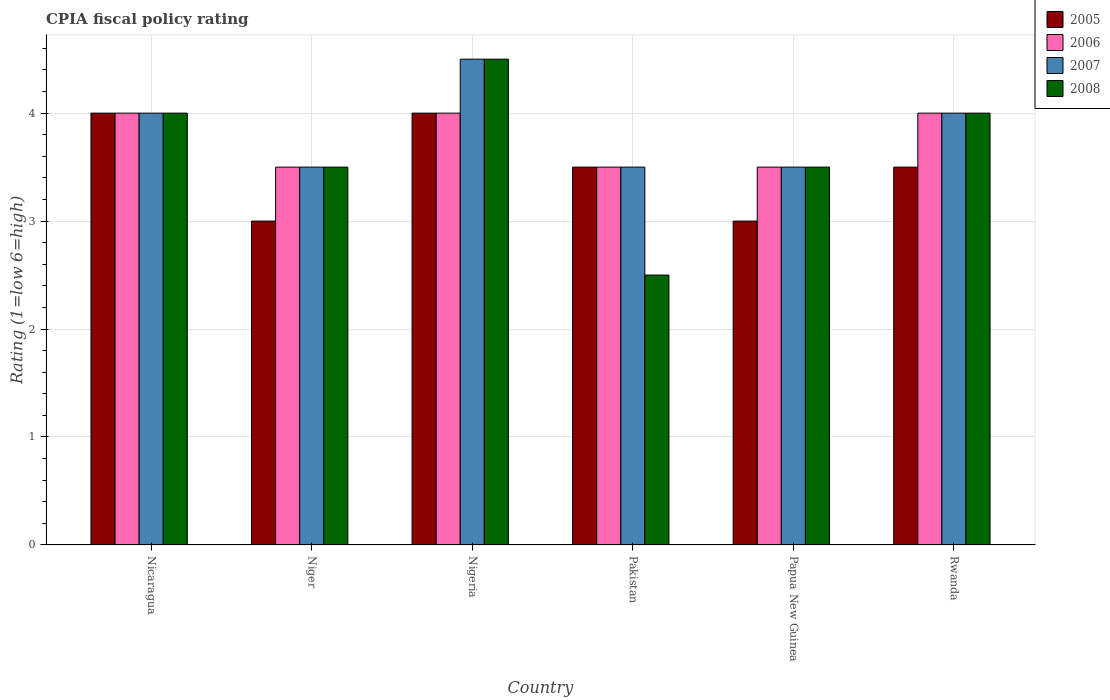How many different coloured bars are there?
Keep it short and to the point. 4. Are the number of bars on each tick of the X-axis equal?
Offer a terse response. Yes. How many bars are there on the 2nd tick from the left?
Provide a short and direct response. 4. What is the label of the 1st group of bars from the left?
Ensure brevity in your answer.  Nicaragua. In how many cases, is the number of bars for a given country not equal to the number of legend labels?
Provide a succinct answer. 0. What is the CPIA rating in 2008 in Rwanda?
Give a very brief answer. 4. Across all countries, what is the minimum CPIA rating in 2006?
Offer a very short reply. 3.5. In which country was the CPIA rating in 2008 maximum?
Give a very brief answer. Nigeria. In which country was the CPIA rating in 2006 minimum?
Offer a terse response. Niger. What is the difference between the CPIA rating in 2007 in Nigeria and the CPIA rating in 2006 in Rwanda?
Provide a short and direct response. 0.5. What is the average CPIA rating in 2008 per country?
Your response must be concise. 3.67. What is the difference between the CPIA rating of/in 2005 and CPIA rating of/in 2006 in Nicaragua?
Your answer should be compact. 0. What is the ratio of the CPIA rating in 2006 in Nicaragua to that in Rwanda?
Your response must be concise. 1. Is it the case that in every country, the sum of the CPIA rating in 2005 and CPIA rating in 2006 is greater than the sum of CPIA rating in 2008 and CPIA rating in 2007?
Offer a terse response. No. What does the 1st bar from the left in Rwanda represents?
Keep it short and to the point. 2005. What does the 3rd bar from the right in Rwanda represents?
Your response must be concise. 2006. Are all the bars in the graph horizontal?
Offer a very short reply. No. Are the values on the major ticks of Y-axis written in scientific E-notation?
Keep it short and to the point. No. Does the graph contain any zero values?
Provide a succinct answer. No. Where does the legend appear in the graph?
Provide a short and direct response. Top right. How are the legend labels stacked?
Offer a terse response. Vertical. What is the title of the graph?
Provide a succinct answer. CPIA fiscal policy rating. What is the label or title of the X-axis?
Keep it short and to the point. Country. What is the Rating (1=low 6=high) of 2005 in Nicaragua?
Your answer should be compact. 4. What is the Rating (1=low 6=high) of 2007 in Nicaragua?
Provide a succinct answer. 4. What is the Rating (1=low 6=high) of 2006 in Niger?
Offer a very short reply. 3.5. What is the Rating (1=low 6=high) in 2007 in Niger?
Ensure brevity in your answer.  3.5. What is the Rating (1=low 6=high) of 2006 in Nigeria?
Your response must be concise. 4. What is the Rating (1=low 6=high) of 2008 in Nigeria?
Your answer should be compact. 4.5. What is the Rating (1=low 6=high) in 2005 in Papua New Guinea?
Make the answer very short. 3. What is the Rating (1=low 6=high) in 2006 in Papua New Guinea?
Ensure brevity in your answer.  3.5. What is the Rating (1=low 6=high) in 2005 in Rwanda?
Your answer should be compact. 3.5. Across all countries, what is the maximum Rating (1=low 6=high) of 2006?
Ensure brevity in your answer.  4. Across all countries, what is the minimum Rating (1=low 6=high) of 2008?
Your response must be concise. 2.5. What is the total Rating (1=low 6=high) in 2005 in the graph?
Provide a succinct answer. 21. What is the total Rating (1=low 6=high) of 2007 in the graph?
Give a very brief answer. 23. What is the difference between the Rating (1=low 6=high) in 2005 in Nicaragua and that in Niger?
Your answer should be compact. 1. What is the difference between the Rating (1=low 6=high) of 2007 in Nicaragua and that in Niger?
Your response must be concise. 0.5. What is the difference between the Rating (1=low 6=high) of 2008 in Nicaragua and that in Niger?
Your response must be concise. 0.5. What is the difference between the Rating (1=low 6=high) of 2005 in Nicaragua and that in Nigeria?
Ensure brevity in your answer.  0. What is the difference between the Rating (1=low 6=high) in 2006 in Nicaragua and that in Nigeria?
Make the answer very short. 0. What is the difference between the Rating (1=low 6=high) of 2008 in Nicaragua and that in Nigeria?
Provide a succinct answer. -0.5. What is the difference between the Rating (1=low 6=high) in 2005 in Nicaragua and that in Pakistan?
Provide a succinct answer. 0.5. What is the difference between the Rating (1=low 6=high) of 2008 in Nicaragua and that in Pakistan?
Provide a short and direct response. 1.5. What is the difference between the Rating (1=low 6=high) in 2006 in Nicaragua and that in Rwanda?
Make the answer very short. 0. What is the difference between the Rating (1=low 6=high) in 2008 in Nicaragua and that in Rwanda?
Provide a short and direct response. 0. What is the difference between the Rating (1=low 6=high) of 2005 in Niger and that in Nigeria?
Offer a terse response. -1. What is the difference between the Rating (1=low 6=high) in 2006 in Niger and that in Nigeria?
Your answer should be very brief. -0.5. What is the difference between the Rating (1=low 6=high) of 2007 in Niger and that in Nigeria?
Provide a succinct answer. -1. What is the difference between the Rating (1=low 6=high) of 2008 in Niger and that in Nigeria?
Make the answer very short. -1. What is the difference between the Rating (1=low 6=high) of 2006 in Niger and that in Pakistan?
Make the answer very short. 0. What is the difference between the Rating (1=low 6=high) in 2007 in Niger and that in Pakistan?
Give a very brief answer. 0. What is the difference between the Rating (1=low 6=high) of 2005 in Niger and that in Papua New Guinea?
Give a very brief answer. 0. What is the difference between the Rating (1=low 6=high) of 2006 in Niger and that in Papua New Guinea?
Offer a very short reply. 0. What is the difference between the Rating (1=low 6=high) in 2007 in Niger and that in Papua New Guinea?
Offer a terse response. 0. What is the difference between the Rating (1=low 6=high) of 2008 in Niger and that in Rwanda?
Your answer should be very brief. -0.5. What is the difference between the Rating (1=low 6=high) of 2006 in Nigeria and that in Pakistan?
Provide a short and direct response. 0.5. What is the difference between the Rating (1=low 6=high) of 2007 in Nigeria and that in Pakistan?
Offer a very short reply. 1. What is the difference between the Rating (1=low 6=high) of 2006 in Nigeria and that in Rwanda?
Keep it short and to the point. 0. What is the difference between the Rating (1=low 6=high) of 2007 in Nigeria and that in Rwanda?
Make the answer very short. 0.5. What is the difference between the Rating (1=low 6=high) of 2008 in Nigeria and that in Rwanda?
Offer a terse response. 0.5. What is the difference between the Rating (1=low 6=high) of 2007 in Pakistan and that in Papua New Guinea?
Make the answer very short. 0. What is the difference between the Rating (1=low 6=high) of 2008 in Pakistan and that in Papua New Guinea?
Offer a very short reply. -1. What is the difference between the Rating (1=low 6=high) of 2005 in Pakistan and that in Rwanda?
Keep it short and to the point. 0. What is the difference between the Rating (1=low 6=high) in 2007 in Pakistan and that in Rwanda?
Keep it short and to the point. -0.5. What is the difference between the Rating (1=low 6=high) in 2005 in Papua New Guinea and that in Rwanda?
Your response must be concise. -0.5. What is the difference between the Rating (1=low 6=high) of 2006 in Papua New Guinea and that in Rwanda?
Offer a very short reply. -0.5. What is the difference between the Rating (1=low 6=high) of 2007 in Papua New Guinea and that in Rwanda?
Ensure brevity in your answer.  -0.5. What is the difference between the Rating (1=low 6=high) of 2008 in Papua New Guinea and that in Rwanda?
Keep it short and to the point. -0.5. What is the difference between the Rating (1=low 6=high) of 2005 in Nicaragua and the Rating (1=low 6=high) of 2006 in Niger?
Provide a succinct answer. 0.5. What is the difference between the Rating (1=low 6=high) of 2005 in Nicaragua and the Rating (1=low 6=high) of 2007 in Niger?
Give a very brief answer. 0.5. What is the difference between the Rating (1=low 6=high) of 2005 in Nicaragua and the Rating (1=low 6=high) of 2008 in Niger?
Offer a terse response. 0.5. What is the difference between the Rating (1=low 6=high) of 2006 in Nicaragua and the Rating (1=low 6=high) of 2007 in Niger?
Your response must be concise. 0.5. What is the difference between the Rating (1=low 6=high) in 2006 in Nicaragua and the Rating (1=low 6=high) in 2008 in Nigeria?
Your answer should be very brief. -0.5. What is the difference between the Rating (1=low 6=high) in 2007 in Nicaragua and the Rating (1=low 6=high) in 2008 in Nigeria?
Ensure brevity in your answer.  -0.5. What is the difference between the Rating (1=low 6=high) of 2005 in Nicaragua and the Rating (1=low 6=high) of 2007 in Pakistan?
Your answer should be very brief. 0.5. What is the difference between the Rating (1=low 6=high) in 2005 in Nicaragua and the Rating (1=low 6=high) in 2008 in Pakistan?
Make the answer very short. 1.5. What is the difference between the Rating (1=low 6=high) in 2006 in Nicaragua and the Rating (1=low 6=high) in 2007 in Pakistan?
Offer a terse response. 0.5. What is the difference between the Rating (1=low 6=high) of 2006 in Nicaragua and the Rating (1=low 6=high) of 2008 in Pakistan?
Give a very brief answer. 1.5. What is the difference between the Rating (1=low 6=high) in 2005 in Nicaragua and the Rating (1=low 6=high) in 2007 in Papua New Guinea?
Your answer should be compact. 0.5. What is the difference between the Rating (1=low 6=high) of 2005 in Nicaragua and the Rating (1=low 6=high) of 2008 in Papua New Guinea?
Give a very brief answer. 0.5. What is the difference between the Rating (1=low 6=high) in 2006 in Nicaragua and the Rating (1=low 6=high) in 2008 in Papua New Guinea?
Offer a terse response. 0.5. What is the difference between the Rating (1=low 6=high) in 2007 in Nicaragua and the Rating (1=low 6=high) in 2008 in Papua New Guinea?
Offer a terse response. 0.5. What is the difference between the Rating (1=low 6=high) of 2005 in Nicaragua and the Rating (1=low 6=high) of 2006 in Rwanda?
Your answer should be very brief. 0. What is the difference between the Rating (1=low 6=high) in 2005 in Nicaragua and the Rating (1=low 6=high) in 2007 in Rwanda?
Ensure brevity in your answer.  0. What is the difference between the Rating (1=low 6=high) in 2005 in Nicaragua and the Rating (1=low 6=high) in 2008 in Rwanda?
Give a very brief answer. 0. What is the difference between the Rating (1=low 6=high) in 2006 in Nicaragua and the Rating (1=low 6=high) in 2007 in Rwanda?
Give a very brief answer. 0. What is the difference between the Rating (1=low 6=high) of 2006 in Nicaragua and the Rating (1=low 6=high) of 2008 in Rwanda?
Your response must be concise. 0. What is the difference between the Rating (1=low 6=high) in 2007 in Nicaragua and the Rating (1=low 6=high) in 2008 in Rwanda?
Your response must be concise. 0. What is the difference between the Rating (1=low 6=high) of 2005 in Niger and the Rating (1=low 6=high) of 2007 in Nigeria?
Your response must be concise. -1.5. What is the difference between the Rating (1=low 6=high) of 2006 in Niger and the Rating (1=low 6=high) of 2007 in Nigeria?
Ensure brevity in your answer.  -1. What is the difference between the Rating (1=low 6=high) of 2005 in Niger and the Rating (1=low 6=high) of 2007 in Pakistan?
Your answer should be compact. -0.5. What is the difference between the Rating (1=low 6=high) of 2006 in Niger and the Rating (1=low 6=high) of 2008 in Pakistan?
Ensure brevity in your answer.  1. What is the difference between the Rating (1=low 6=high) of 2007 in Niger and the Rating (1=low 6=high) of 2008 in Pakistan?
Ensure brevity in your answer.  1. What is the difference between the Rating (1=low 6=high) in 2005 in Niger and the Rating (1=low 6=high) in 2007 in Papua New Guinea?
Keep it short and to the point. -0.5. What is the difference between the Rating (1=low 6=high) in 2005 in Niger and the Rating (1=low 6=high) in 2008 in Papua New Guinea?
Offer a very short reply. -0.5. What is the difference between the Rating (1=low 6=high) in 2007 in Niger and the Rating (1=low 6=high) in 2008 in Papua New Guinea?
Make the answer very short. 0. What is the difference between the Rating (1=low 6=high) in 2005 in Niger and the Rating (1=low 6=high) in 2006 in Rwanda?
Provide a succinct answer. -1. What is the difference between the Rating (1=low 6=high) in 2005 in Niger and the Rating (1=low 6=high) in 2007 in Rwanda?
Keep it short and to the point. -1. What is the difference between the Rating (1=low 6=high) of 2005 in Niger and the Rating (1=low 6=high) of 2008 in Rwanda?
Your answer should be compact. -1. What is the difference between the Rating (1=low 6=high) of 2005 in Nigeria and the Rating (1=low 6=high) of 2007 in Pakistan?
Make the answer very short. 0.5. What is the difference between the Rating (1=low 6=high) of 2005 in Nigeria and the Rating (1=low 6=high) of 2008 in Pakistan?
Keep it short and to the point. 1.5. What is the difference between the Rating (1=low 6=high) of 2006 in Nigeria and the Rating (1=low 6=high) of 2008 in Pakistan?
Ensure brevity in your answer.  1.5. What is the difference between the Rating (1=low 6=high) of 2005 in Nigeria and the Rating (1=low 6=high) of 2008 in Papua New Guinea?
Ensure brevity in your answer.  0.5. What is the difference between the Rating (1=low 6=high) of 2006 in Nigeria and the Rating (1=low 6=high) of 2008 in Papua New Guinea?
Your response must be concise. 0.5. What is the difference between the Rating (1=low 6=high) in 2005 in Nigeria and the Rating (1=low 6=high) in 2006 in Rwanda?
Keep it short and to the point. 0. What is the difference between the Rating (1=low 6=high) of 2005 in Nigeria and the Rating (1=low 6=high) of 2008 in Rwanda?
Provide a succinct answer. 0. What is the difference between the Rating (1=low 6=high) of 2006 in Pakistan and the Rating (1=low 6=high) of 2007 in Papua New Guinea?
Your answer should be compact. 0. What is the difference between the Rating (1=low 6=high) of 2006 in Pakistan and the Rating (1=low 6=high) of 2008 in Papua New Guinea?
Offer a very short reply. 0. What is the difference between the Rating (1=low 6=high) in 2007 in Pakistan and the Rating (1=low 6=high) in 2008 in Papua New Guinea?
Your answer should be very brief. 0. What is the difference between the Rating (1=low 6=high) in 2005 in Pakistan and the Rating (1=low 6=high) in 2008 in Rwanda?
Your answer should be compact. -0.5. What is the difference between the Rating (1=low 6=high) in 2006 in Pakistan and the Rating (1=low 6=high) in 2007 in Rwanda?
Make the answer very short. -0.5. What is the difference between the Rating (1=low 6=high) of 2006 in Pakistan and the Rating (1=low 6=high) of 2008 in Rwanda?
Offer a very short reply. -0.5. What is the difference between the Rating (1=low 6=high) of 2007 in Pakistan and the Rating (1=low 6=high) of 2008 in Rwanda?
Provide a short and direct response. -0.5. What is the difference between the Rating (1=low 6=high) of 2005 in Papua New Guinea and the Rating (1=low 6=high) of 2006 in Rwanda?
Offer a very short reply. -1. What is the difference between the Rating (1=low 6=high) in 2005 in Papua New Guinea and the Rating (1=low 6=high) in 2007 in Rwanda?
Ensure brevity in your answer.  -1. What is the difference between the Rating (1=low 6=high) in 2006 in Papua New Guinea and the Rating (1=low 6=high) in 2007 in Rwanda?
Your answer should be compact. -0.5. What is the difference between the Rating (1=low 6=high) of 2006 in Papua New Guinea and the Rating (1=low 6=high) of 2008 in Rwanda?
Keep it short and to the point. -0.5. What is the difference between the Rating (1=low 6=high) of 2007 in Papua New Guinea and the Rating (1=low 6=high) of 2008 in Rwanda?
Your answer should be very brief. -0.5. What is the average Rating (1=low 6=high) of 2006 per country?
Provide a short and direct response. 3.75. What is the average Rating (1=low 6=high) of 2007 per country?
Provide a short and direct response. 3.83. What is the average Rating (1=low 6=high) of 2008 per country?
Make the answer very short. 3.67. What is the difference between the Rating (1=low 6=high) in 2005 and Rating (1=low 6=high) in 2007 in Nicaragua?
Offer a terse response. 0. What is the difference between the Rating (1=low 6=high) in 2006 and Rating (1=low 6=high) in 2007 in Nicaragua?
Give a very brief answer. 0. What is the difference between the Rating (1=low 6=high) of 2006 and Rating (1=low 6=high) of 2008 in Nicaragua?
Your answer should be compact. 0. What is the difference between the Rating (1=low 6=high) in 2007 and Rating (1=low 6=high) in 2008 in Nicaragua?
Provide a succinct answer. 0. What is the difference between the Rating (1=low 6=high) in 2005 and Rating (1=low 6=high) in 2006 in Nigeria?
Your answer should be very brief. 0. What is the difference between the Rating (1=low 6=high) of 2005 and Rating (1=low 6=high) of 2007 in Nigeria?
Your response must be concise. -0.5. What is the difference between the Rating (1=low 6=high) in 2005 and Rating (1=low 6=high) in 2008 in Nigeria?
Your answer should be compact. -0.5. What is the difference between the Rating (1=low 6=high) in 2006 and Rating (1=low 6=high) in 2007 in Nigeria?
Provide a succinct answer. -0.5. What is the difference between the Rating (1=low 6=high) of 2007 and Rating (1=low 6=high) of 2008 in Nigeria?
Keep it short and to the point. 0. What is the difference between the Rating (1=low 6=high) of 2005 and Rating (1=low 6=high) of 2008 in Pakistan?
Offer a terse response. 1. What is the difference between the Rating (1=low 6=high) of 2006 and Rating (1=low 6=high) of 2007 in Pakistan?
Make the answer very short. 0. What is the difference between the Rating (1=low 6=high) of 2005 and Rating (1=low 6=high) of 2006 in Papua New Guinea?
Your response must be concise. -0.5. What is the difference between the Rating (1=low 6=high) in 2006 and Rating (1=low 6=high) in 2007 in Papua New Guinea?
Make the answer very short. 0. What is the difference between the Rating (1=low 6=high) of 2006 and Rating (1=low 6=high) of 2008 in Papua New Guinea?
Your response must be concise. 0. What is the difference between the Rating (1=low 6=high) in 2007 and Rating (1=low 6=high) in 2008 in Papua New Guinea?
Your response must be concise. 0. What is the difference between the Rating (1=low 6=high) of 2006 and Rating (1=low 6=high) of 2007 in Rwanda?
Your response must be concise. 0. What is the difference between the Rating (1=low 6=high) of 2007 and Rating (1=low 6=high) of 2008 in Rwanda?
Offer a very short reply. 0. What is the ratio of the Rating (1=low 6=high) in 2007 in Nicaragua to that in Niger?
Your answer should be compact. 1.14. What is the ratio of the Rating (1=low 6=high) of 2005 in Nicaragua to that in Nigeria?
Your answer should be compact. 1. What is the ratio of the Rating (1=low 6=high) of 2008 in Nicaragua to that in Nigeria?
Your response must be concise. 0.89. What is the ratio of the Rating (1=low 6=high) of 2008 in Nicaragua to that in Pakistan?
Make the answer very short. 1.6. What is the ratio of the Rating (1=low 6=high) in 2007 in Nicaragua to that in Papua New Guinea?
Provide a short and direct response. 1.14. What is the ratio of the Rating (1=low 6=high) in 2008 in Nicaragua to that in Papua New Guinea?
Offer a terse response. 1.14. What is the ratio of the Rating (1=low 6=high) of 2005 in Nicaragua to that in Rwanda?
Keep it short and to the point. 1.14. What is the ratio of the Rating (1=low 6=high) in 2007 in Nicaragua to that in Rwanda?
Give a very brief answer. 1. What is the ratio of the Rating (1=low 6=high) in 2008 in Nicaragua to that in Rwanda?
Keep it short and to the point. 1. What is the ratio of the Rating (1=low 6=high) of 2006 in Niger to that in Nigeria?
Provide a succinct answer. 0.88. What is the ratio of the Rating (1=low 6=high) in 2006 in Niger to that in Pakistan?
Your answer should be very brief. 1. What is the ratio of the Rating (1=low 6=high) in 2008 in Niger to that in Pakistan?
Offer a very short reply. 1.4. What is the ratio of the Rating (1=low 6=high) of 2006 in Niger to that in Papua New Guinea?
Offer a very short reply. 1. What is the ratio of the Rating (1=low 6=high) of 2007 in Niger to that in Papua New Guinea?
Provide a short and direct response. 1. What is the ratio of the Rating (1=low 6=high) of 2006 in Niger to that in Rwanda?
Ensure brevity in your answer.  0.88. What is the ratio of the Rating (1=low 6=high) of 2007 in Niger to that in Rwanda?
Your answer should be compact. 0.88. What is the ratio of the Rating (1=low 6=high) in 2008 in Niger to that in Rwanda?
Provide a succinct answer. 0.88. What is the ratio of the Rating (1=low 6=high) of 2006 in Nigeria to that in Pakistan?
Provide a succinct answer. 1.14. What is the ratio of the Rating (1=low 6=high) in 2007 in Nigeria to that in Pakistan?
Provide a short and direct response. 1.29. What is the ratio of the Rating (1=low 6=high) of 2007 in Nigeria to that in Papua New Guinea?
Provide a succinct answer. 1.29. What is the ratio of the Rating (1=low 6=high) in 2005 in Nigeria to that in Rwanda?
Keep it short and to the point. 1.14. What is the ratio of the Rating (1=low 6=high) of 2006 in Nigeria to that in Rwanda?
Ensure brevity in your answer.  1. What is the ratio of the Rating (1=low 6=high) in 2007 in Nigeria to that in Rwanda?
Your answer should be very brief. 1.12. What is the ratio of the Rating (1=low 6=high) in 2008 in Nigeria to that in Rwanda?
Keep it short and to the point. 1.12. What is the ratio of the Rating (1=low 6=high) in 2008 in Pakistan to that in Papua New Guinea?
Provide a succinct answer. 0.71. What is the ratio of the Rating (1=low 6=high) in 2007 in Pakistan to that in Rwanda?
Your answer should be very brief. 0.88. What is the ratio of the Rating (1=low 6=high) in 2008 in Pakistan to that in Rwanda?
Give a very brief answer. 0.62. What is the difference between the highest and the second highest Rating (1=low 6=high) in 2006?
Provide a succinct answer. 0. What is the difference between the highest and the second highest Rating (1=low 6=high) of 2007?
Ensure brevity in your answer.  0.5. What is the difference between the highest and the lowest Rating (1=low 6=high) in 2005?
Offer a terse response. 1. What is the difference between the highest and the lowest Rating (1=low 6=high) of 2008?
Give a very brief answer. 2. 